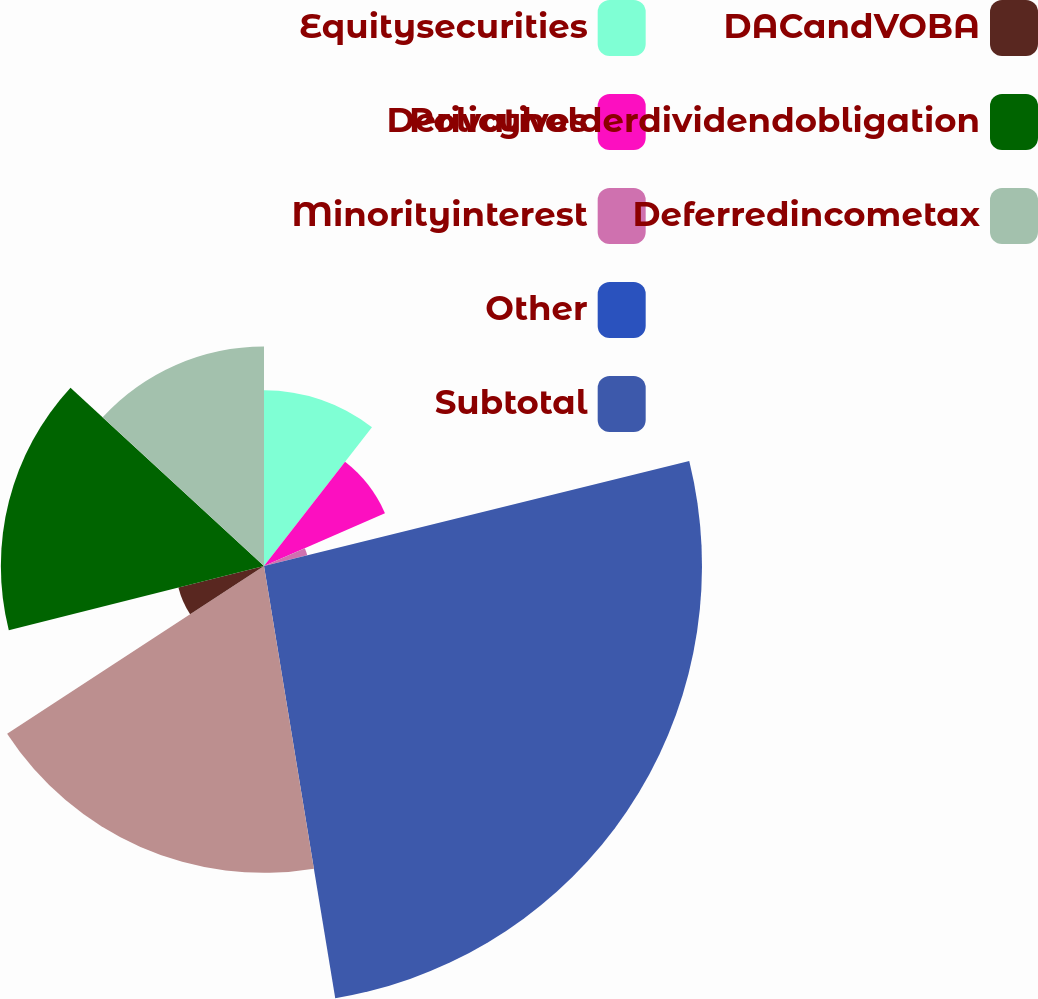<chart> <loc_0><loc_0><loc_500><loc_500><pie_chart><fcel>Equitysecurities<fcel>Derivatives<fcel>Minorityinterest<fcel>Other<fcel>Subtotal<fcel>Unnamed: 5<fcel>DACandVOBA<fcel>Policyholderdividendobligation<fcel>Deferredincometax<nl><fcel>10.53%<fcel>7.91%<fcel>2.67%<fcel>0.04%<fcel>26.25%<fcel>18.39%<fcel>5.29%<fcel>15.77%<fcel>13.15%<nl></chart> 